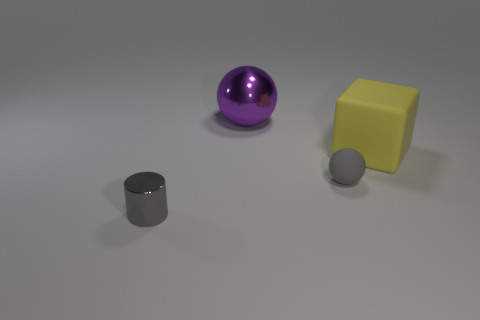Add 1 red shiny spheres. How many objects exist? 5 Subtract all cylinders. How many objects are left? 3 Subtract all small gray rubber balls. Subtract all yellow objects. How many objects are left? 2 Add 1 matte spheres. How many matte spheres are left? 2 Add 2 tiny matte objects. How many tiny matte objects exist? 3 Subtract 0 green cylinders. How many objects are left? 4 